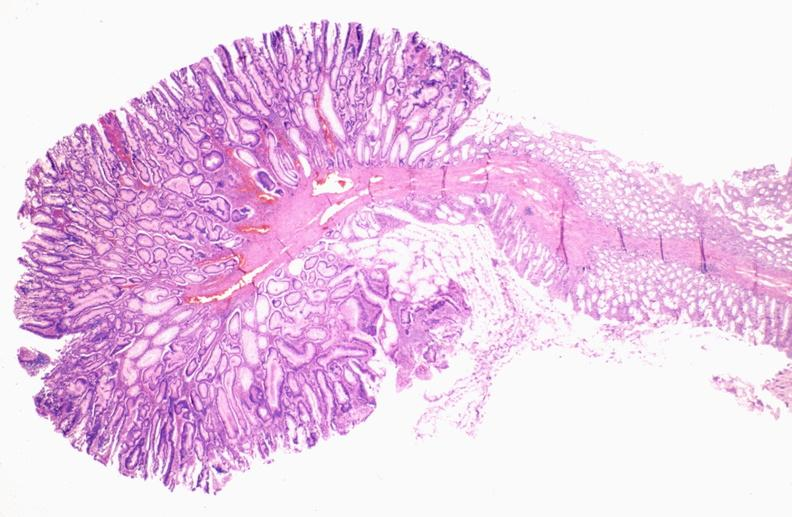where is this from?
Answer the question using a single word or phrase. Gastrointestinal system 